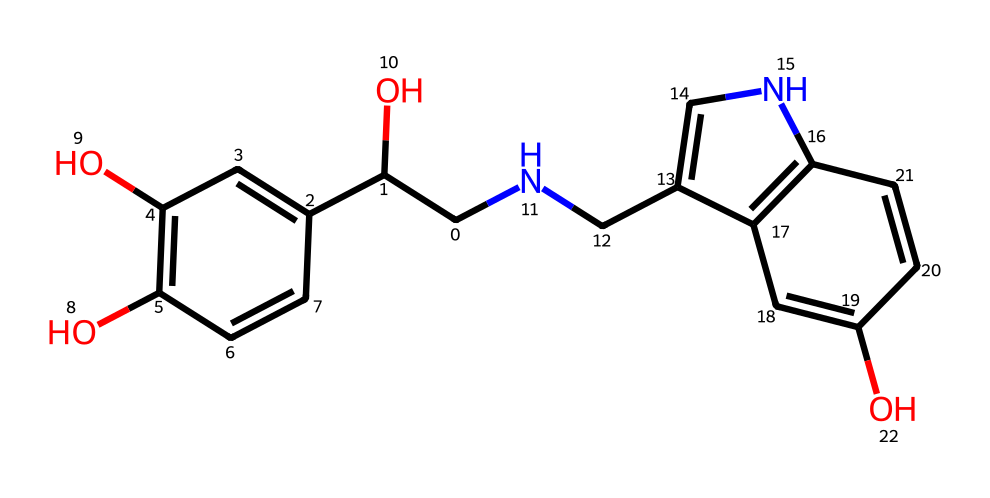What is the chemical name of this compound? The SMILES representation corresponds to a specific arrangement of atoms which can be deduced to determine the name. Analyzing the structure reveals that it is structurally similar to epinephrine, also known as adrenaline, which is a well-known hormone.
Answer: adrenaline How many rings are present in the chemical structure? By examining the SMILES representation, the presence of aromatic rings can be identified by looking for cyclic arrangements of carbon atoms with alternating double bonds. Here, there are two distinct aromatic rings evident in the structure.
Answer: 2 What is the primary functional group in adrenaline? Looking at the structure, the hydroxyl (-OH) groups can be identified. This specific type of group results in polarity and solubility properties. There are two hydroxyl functional groups in the structure, indicating it has multiple sites for hydrogen bonding.
Answer: hydroxyl How many chiral centers does adrenaline have? Chiral centers are identified by looking for carbon atoms that are bonded to four different groups. In the provided structure, there are two such carbon centers that fulfill this criterion, leading to chirality in the molecule.
Answer: 2 What is the molecular formula of adrenaline? By counting the individual atoms represented in the SMILES notation, we can derive the elemental composition. The structure has 9 carbon atoms, 13 hydrogen atoms, 3 oxygen atoms, and 1 nitrogen atom, leading to the formula C9H13NO3.
Answer: C9H13NO3 What type of hormone is adrenaline classified as? Based on its structure and function, adrenaline is classified as a catecholamine hormone. This classification is particularly associated with hormones derived from the amino acid tyrosine that have a catechol moiety.
Answer: catecholamine 